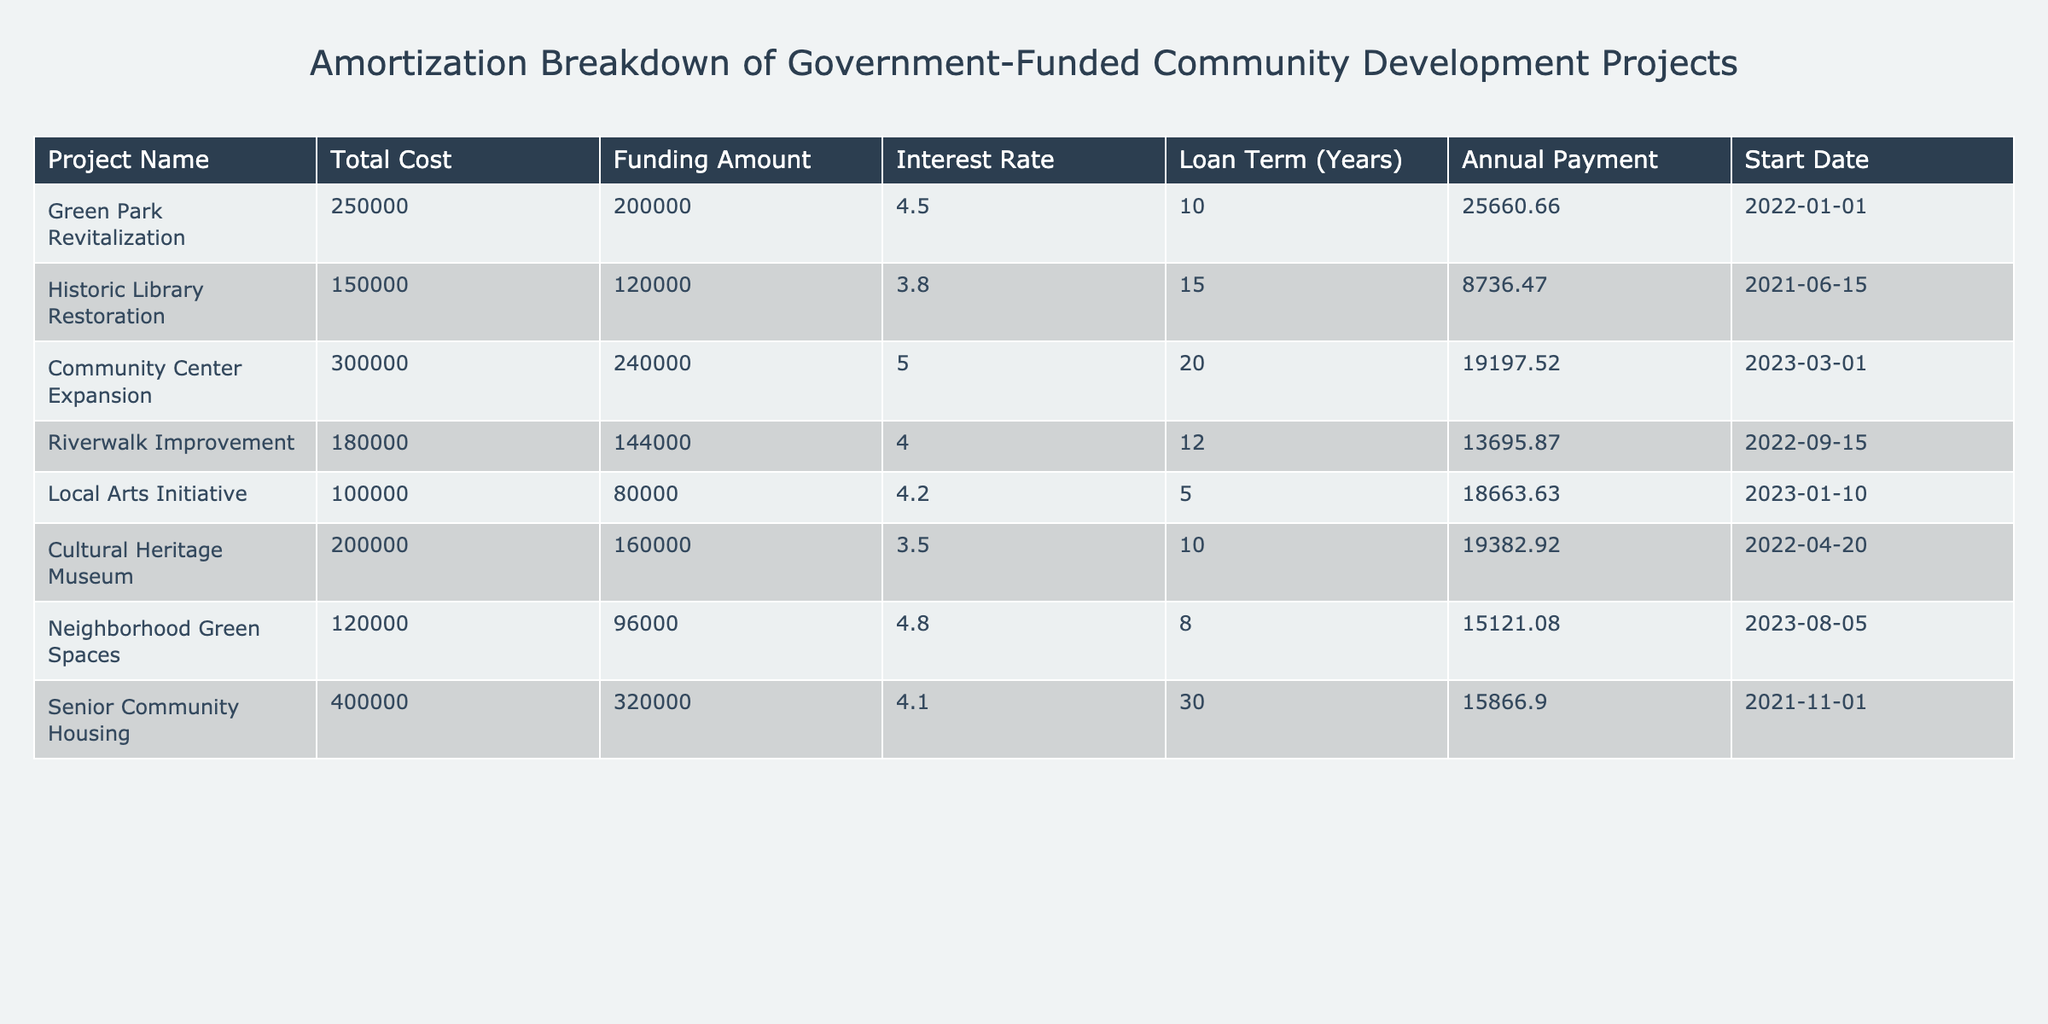What is the interest rate for the Historic Library Restoration project? The table lists the interest rate column, under which the Historic Library Restoration project is found. Its corresponding interest rate is 3.8%.
Answer: 3.8% Which project has the highest annual payment? By reviewing the annual payment column in the table, the project with the highest annual payment is the Local Arts Initiative, with an annual payment of 18663.63.
Answer: Local Arts Initiative What is the total funding amount for all projects combined? To find the total funding amount, add all the funding amounts in the table: 200000 + 120000 + 240000 + 144000 + 80000 + 160000 + 96000 + 320000 = 1120000.
Answer: 1120000 Is the Riverwalk Improvement project funded with less than 80% of its total cost? First, calculate the funding percentage: (Funding Amount / Total Cost) * 100 = (144000 / 180000) * 100 = 80%. Since the project is funded at exactly 80%, the answer is no, it is not less than 80%.
Answer: No Which project has the longest loan term and what is its annual payment? Reviewing the loan term column reveals that the Senior Community Housing project has the longest loan term of 30 years. Its corresponding annual payment is 15866.90.
Answer: Senior Community Housing, 15866.90 What is the difference in annual payments between the Green Park Revitalization and the Cultural Heritage Museum? To find the difference, subtract the Cultural Heritage Museum’s annual payment from the Green Park Revitalization’s annual payment: 25660.66 - 19382.92 = 6267.74.
Answer: 6267.74 How many projects have an interest rate greater than 4%? Count the projects with an interest rate greater than 4%. These projects are Green Park Revitalization (4.5), Community Center Expansion (5.0), Riverwalk Improvement (4.0), Local Arts Initiative (4.2), and Senior Community Housing (4.1) totaling 5 projects.
Answer: 5 What is the average annual payment for the projects funded above 200,000? First, identify the projects with funding amounts greater than 200,000: Community Center Expansion (19197.52), and Senior Community Housing (15866.90). Next, calculate the average: (19197.52 + 15866.90) / 2 = 17582.21.
Answer: 17582.21 